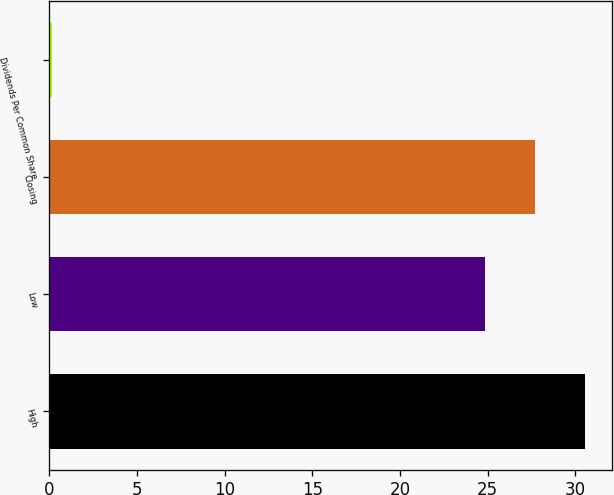Convert chart to OTSL. <chart><loc_0><loc_0><loc_500><loc_500><bar_chart><fcel>High<fcel>Low<fcel>Closing<fcel>Dividends Per Common Share<nl><fcel>30.57<fcel>24.86<fcel>27.71<fcel>0.12<nl></chart> 